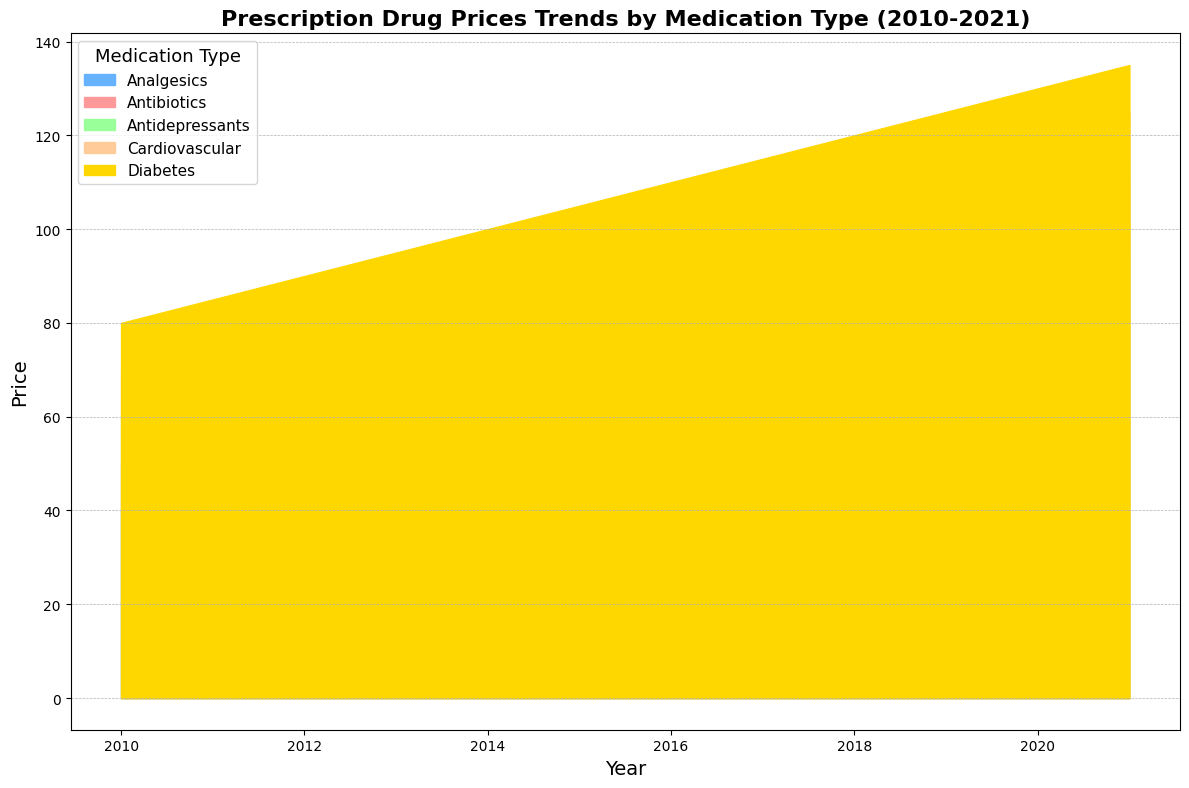What is the range of prices for Antibiotics from 2010 to 2021? The range of prices is the difference between the highest price in 2021 and the lowest price in 2010. From the figure, the highest price for Antibiotics in 2021 is $110 and the lowest price in 2010 is $50. Therefore, the range is $110 - $50 = $60.
Answer: $60 How do the prices of Analgesics compare to Antidepressants in 2020? From the figure, the price of Analgesics in 2020 is $90, and the price of Antidepressants in 2020 is $110. By comparing these values, we can see that the price of Antidepressants is higher than Analgesics in 2020.
Answer: Antidepressants cost more than Analgesics Which medication type had the highest price increase over this period? To determine the highest price increase, we compare the increase in price for each medication type from 2010 to 2021. Antibiotics increased from $50 to $110, Analgesics from $40 to $95, Antidepressants from $60 to $115, Cardiovascular from $70 to $125, and Diabetes from $80 to $135. The highest increase is for Diabetes, which increased by $55.
Answer: Diabetes What was the price trend for Cardiovascular medications from 2010 to 2021? The price trend for Cardiovascular medications increased steadily from 2010 to 2021. The prices start at $70 in 2010 and increase incrementally each year to reach $125 in 2021. This shows a consistent upward trend.
Answer: Steadily increasing Which medication type had the smallest price increase from 2010 to 2015? To find the smallest increase, we look at the price difference for each medication type between 2010 and 2015. Antibiotics increased from $50 to $80 ($30), Analgesics from $40 to $65 ($25), Antidepressants from $60 to $85 ($25), Cardiovascular from $70 to $95 ($25), and Diabetes from $80 to $105 ($25). The smallest increase is shared by Analgesics, Antidepressants, Cardiovascular, and Diabetes, all at $25.
Answer: Analgesics, Antidepressants, Cardiovascular, Diabetes What was the price of Diabetes medication in 2018 and how does it compare to the price in 2014? From the figure, the price of Diabetes medication in 2018 is $120 and in 2014 it is $100. Comparing these prices, the 2018 price is $20 higher than the 2014 price.
Answer: $20 higher What is the average price of Antidepressants over the period from 2010 to 2021? The average price is calculated by summing the prices for each year and then dividing by the number of years. The prices of Antidepressants from 2010 to 2021 are $60, $65, $70, $75, $80, $85, $90, $95, $100, $105, $110, and $115. The sum is $1050 and there are 12 years, so the average is $1050 / 12 = $87.50.
Answer: $87.50 